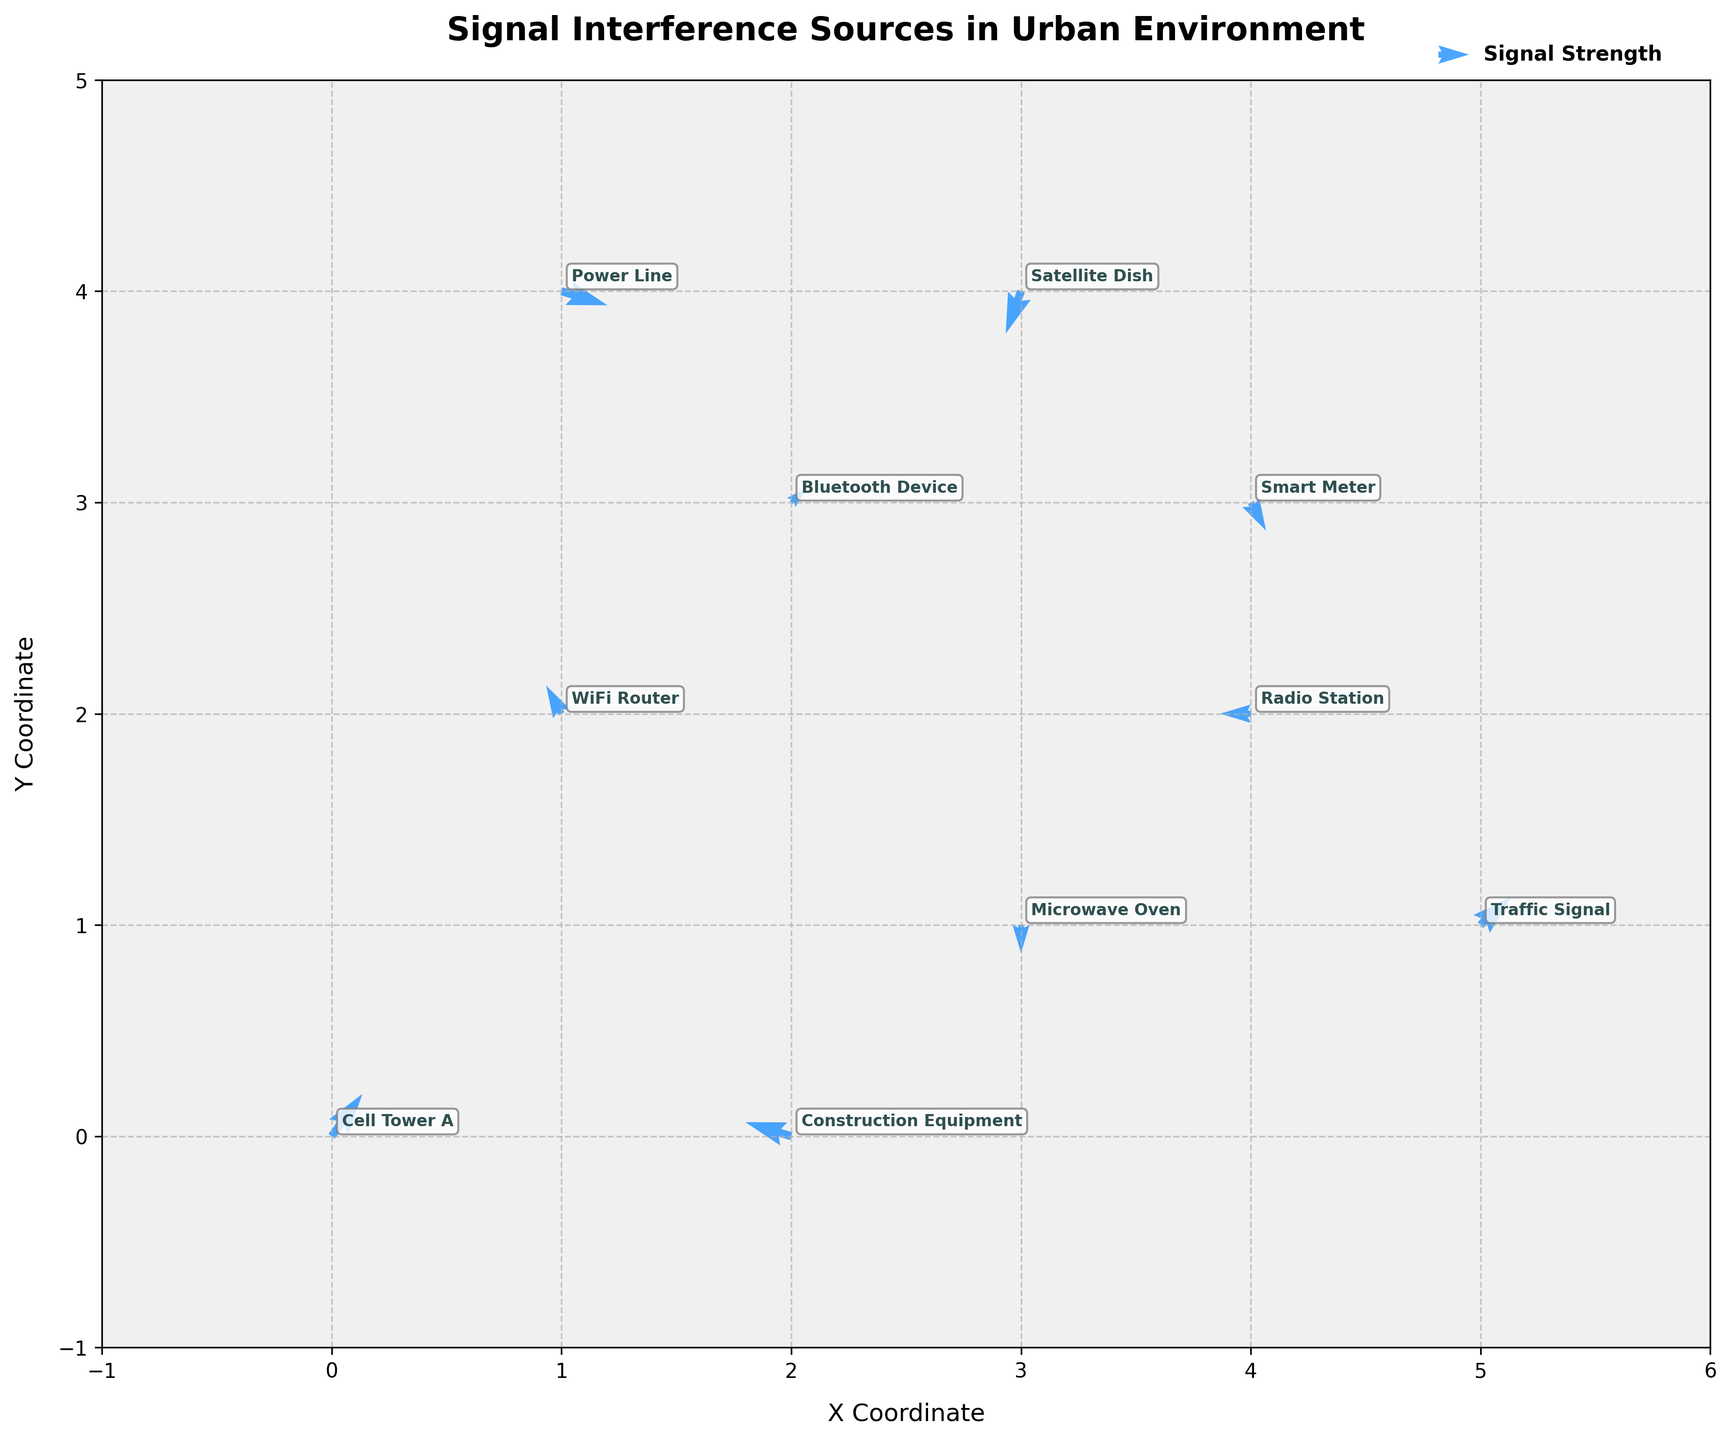what is the title of the plot? The title is given at the top of the plot and describes the subject or main point of the figure. In this case, it reads "Signal Interference Sources in Urban Environment".
Answer: Signal Interference Sources in Urban Environment How many different interference sources are shown in the plot? Each source is labeled in the plot with corresponding vectors indicating direction and magnitude. By counting these labels, we can see that there are 10 different sources.
Answer: 10 Which interference source has the strongest signal strength? To determine the signal strength, we look at the magnitude of the vectors. The Power Line at coordinates (1, 4) has a large vector (3, -1), making it the strongest signal in terms of vector length.
Answer: Power Line Which source has a signal moving vertically downward? Vertical movement downward is indicated by the vector with a negative y-component and a zero x-component. The Microwave Oven at (3, 1) has a vector (0, -2), which fits this description.
Answer: Microwave Oven How does the direction of the Cellular Tower A signal compare with the Traffic Signal? The Cell Tower A (0, 0) has a vector (2, 3), representing movement to the upper right. The Traffic Signal (5, 1) has a vector (2, 2), also moving to the upper right but with a slightly lesser vertical component. Both move in a similar direction.
Answer: Similar direction What is the primary direction of the Bluetooth Device's signal? The Bluetooth Device is located at (2, 3) with a vector (1, 1). This signifies a diagonal movement towards the upper right.
Answer: upper right Compare the signals from the Radio Station and Satellite Dish. Which is stronger and what is their respective direction? The Radio Station (4, 2) vector is (-2, 0) going horizontally left with a strength of 2. The Satellite Dish (3, 4) vector is (-1, -3) going diagonally to the lower left with a strength of √(1² + 3²) or roughly 3.16. The Satellite Dish has the stronger signal.
Answer: Satellite Dish is stronger, directions are left and lower left Describe the signal interference sourced from the Construction Equipment. The Construction Equipment at (2, 0) has a vector (-3, 1). This indicates a strong signal moving diagonally toward the upper left with a magnitude of √(3² + 1²) or about 3.16.
Answer: upper left Which interference source has a signal moving primarily on the x-axis? Movement primarily on the x-axis implies the y-component of the vector is zero. The Radio Station at (4, 2) with the vector (-2, 0) fits this description, moving horizontally left.
Answer: Radio Station Combine the overall direction of the signals from the Smart Meter and Cell Tower A. What is the resultant direction? The Smart Meter at (4, 3) has a vector (1, -2), and the Cell Tower A at (0, 0) has a vector (2, 3). Adding these vectors: (1 + 2, -2 + 3) = (3, 1), which points toward the upper right.
Answer: upper right 